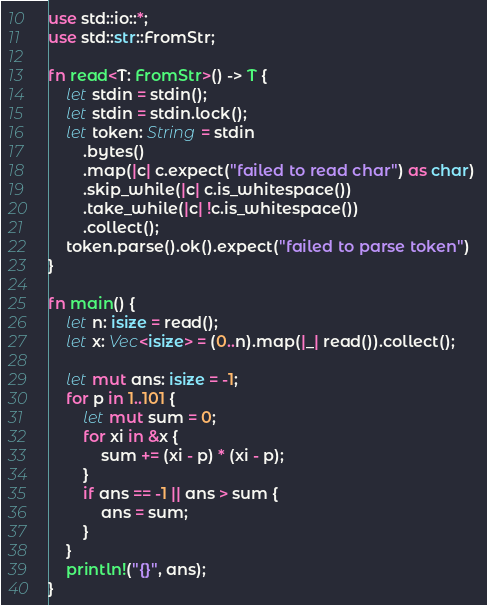<code> <loc_0><loc_0><loc_500><loc_500><_Rust_>use std::io::*;
use std::str::FromStr;

fn read<T: FromStr>() -> T {
    let stdin = stdin();
    let stdin = stdin.lock();
    let token: String = stdin
        .bytes()
        .map(|c| c.expect("failed to read char") as char) 
        .skip_while(|c| c.is_whitespace())
        .take_while(|c| !c.is_whitespace())
        .collect();
    token.parse().ok().expect("failed to parse token")
}

fn main() {
    let n: isize = read();
    let x: Vec<isize> = (0..n).map(|_| read()).collect();

    let mut ans: isize = -1;
    for p in 1..101 {
        let mut sum = 0;
        for xi in &x {
            sum += (xi - p) * (xi - p);
        }
        if ans == -1 || ans > sum {
            ans = sum;
        }
    }
    println!("{}", ans);
}
</code> 